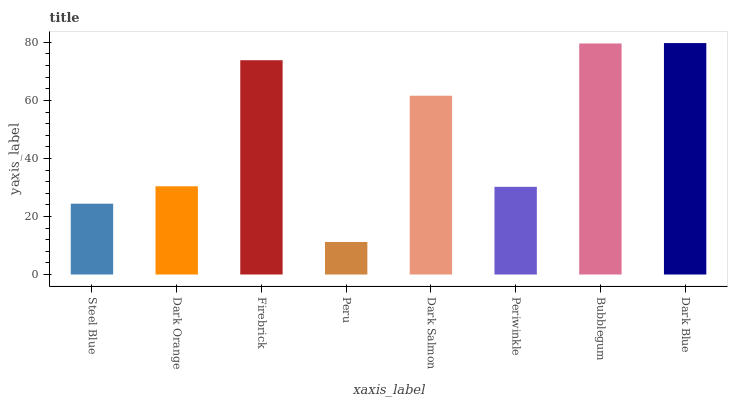Is Peru the minimum?
Answer yes or no. Yes. Is Dark Blue the maximum?
Answer yes or no. Yes. Is Dark Orange the minimum?
Answer yes or no. No. Is Dark Orange the maximum?
Answer yes or no. No. Is Dark Orange greater than Steel Blue?
Answer yes or no. Yes. Is Steel Blue less than Dark Orange?
Answer yes or no. Yes. Is Steel Blue greater than Dark Orange?
Answer yes or no. No. Is Dark Orange less than Steel Blue?
Answer yes or no. No. Is Dark Salmon the high median?
Answer yes or no. Yes. Is Dark Orange the low median?
Answer yes or no. Yes. Is Peru the high median?
Answer yes or no. No. Is Periwinkle the low median?
Answer yes or no. No. 